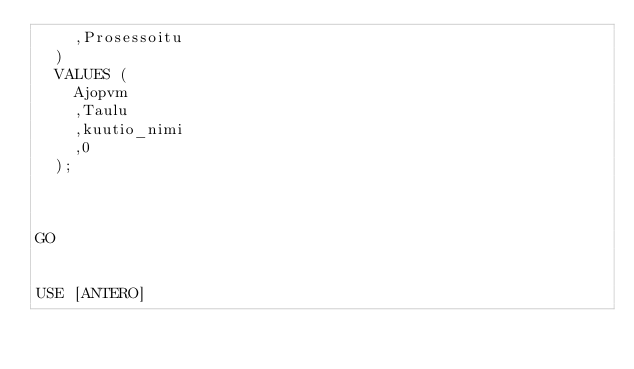Convert code to text. <code><loc_0><loc_0><loc_500><loc_500><_SQL_>	,Prosessoitu
  )
  VALUES (
	Ajopvm
	,Taulu
	,kuutio_nimi
	,0
  );



GO


USE [ANTERO]</code> 